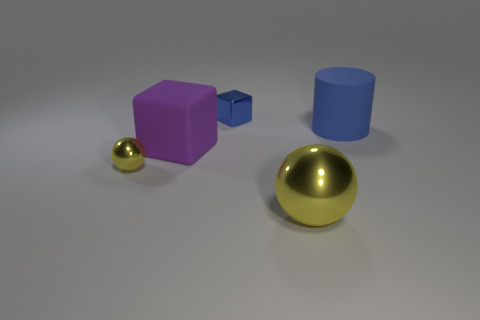Add 2 small metallic blocks. How many objects exist? 7 Subtract all balls. How many objects are left? 3 Subtract all tiny things. Subtract all big purple matte objects. How many objects are left? 2 Add 4 yellow things. How many yellow things are left? 6 Add 1 matte objects. How many matte objects exist? 3 Subtract 0 gray blocks. How many objects are left? 5 